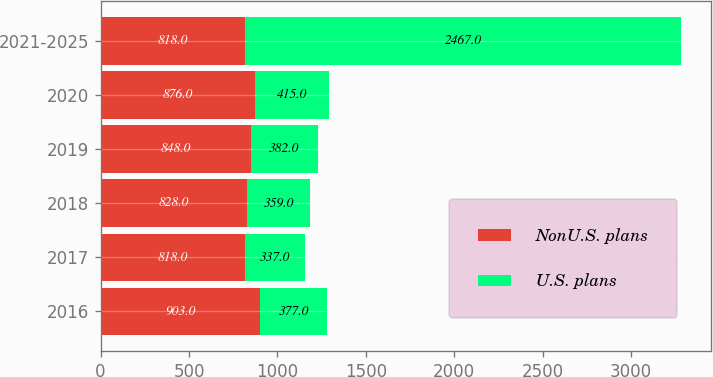<chart> <loc_0><loc_0><loc_500><loc_500><stacked_bar_chart><ecel><fcel>2016<fcel>2017<fcel>2018<fcel>2019<fcel>2020<fcel>2021-2025<nl><fcel>NonU.S. plans<fcel>903<fcel>818<fcel>828<fcel>848<fcel>876<fcel>818<nl><fcel>U.S. plans<fcel>377<fcel>337<fcel>359<fcel>382<fcel>415<fcel>2467<nl></chart> 